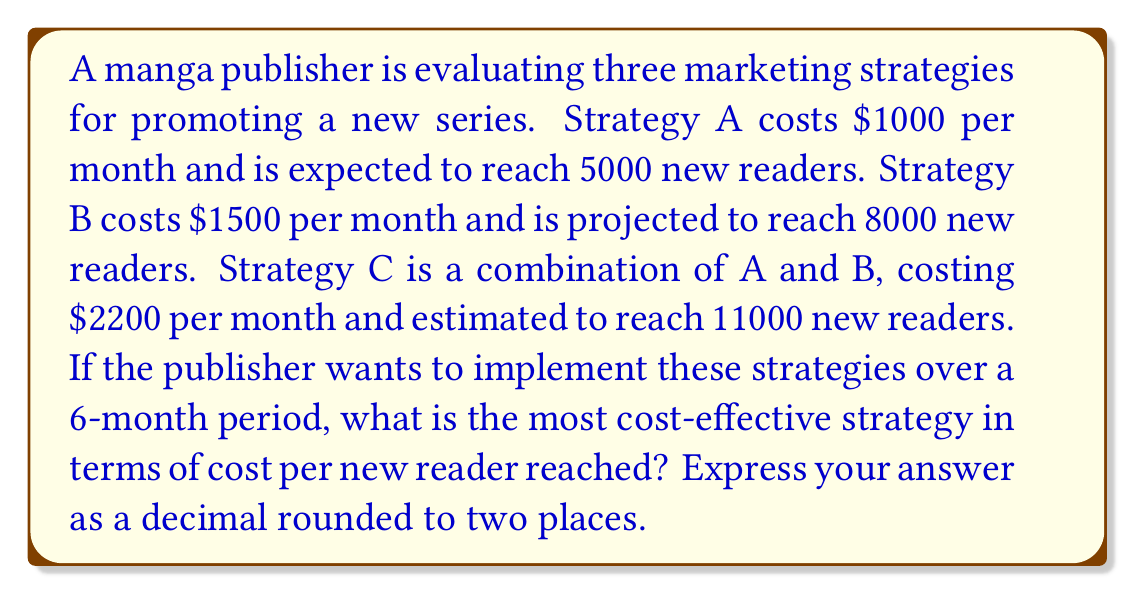Teach me how to tackle this problem. To determine the most cost-effective strategy, we need to calculate the cost per new reader for each strategy over the 6-month period.

1. Calculate total cost for each strategy over 6 months:
   Strategy A: $1000 * 6 = $6000
   Strategy B: $1500 * 6 = $9000
   Strategy C: $2200 * 6 = $13200

2. Calculate total readers reached over 6 months:
   Strategy A: 5000 * 6 = 30000
   Strategy B: 8000 * 6 = 48000
   Strategy C: 11000 * 6 = 66000

3. Calculate cost per reader for each strategy:
   Strategy A: $\frac{6000}{30000} = 0.20$ per reader
   Strategy B: $\frac{9000}{48000} = 0.1875$ per reader
   Strategy C: $\frac{13200}{66000} = 0.20$ per reader

4. Compare the results:
   Strategy B has the lowest cost per reader at $0.1875, making it the most cost-effective.

5. Round the answer to two decimal places:
   $0.1875 \approx 0.19$
Answer: $0.19 